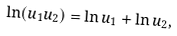Convert formula to latex. <formula><loc_0><loc_0><loc_500><loc_500>\ln ( u _ { 1 } u _ { 2 } ) = \ln u _ { 1 } + \ln u _ { 2 } ,</formula> 